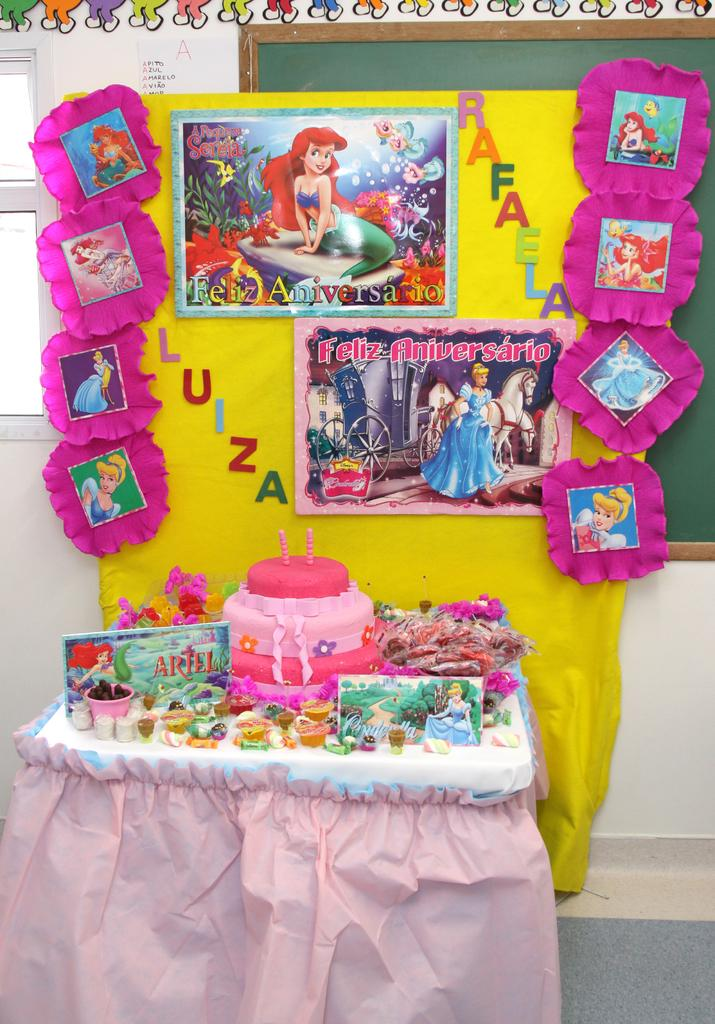What is the main object in the center of the image? There is a table in the center of the image. What is placed on the table? There is a cake on the table. What can be seen in the background of the image? There is a wall in the background of the image. What is on the wall? Posters are sticked on the wall. Can you see a carriage being pulled by a horse in the image? No, there is no carriage or horse present in the image. Is there a bee buzzing around the cake in the image? No, there is no bee visible in the image. 